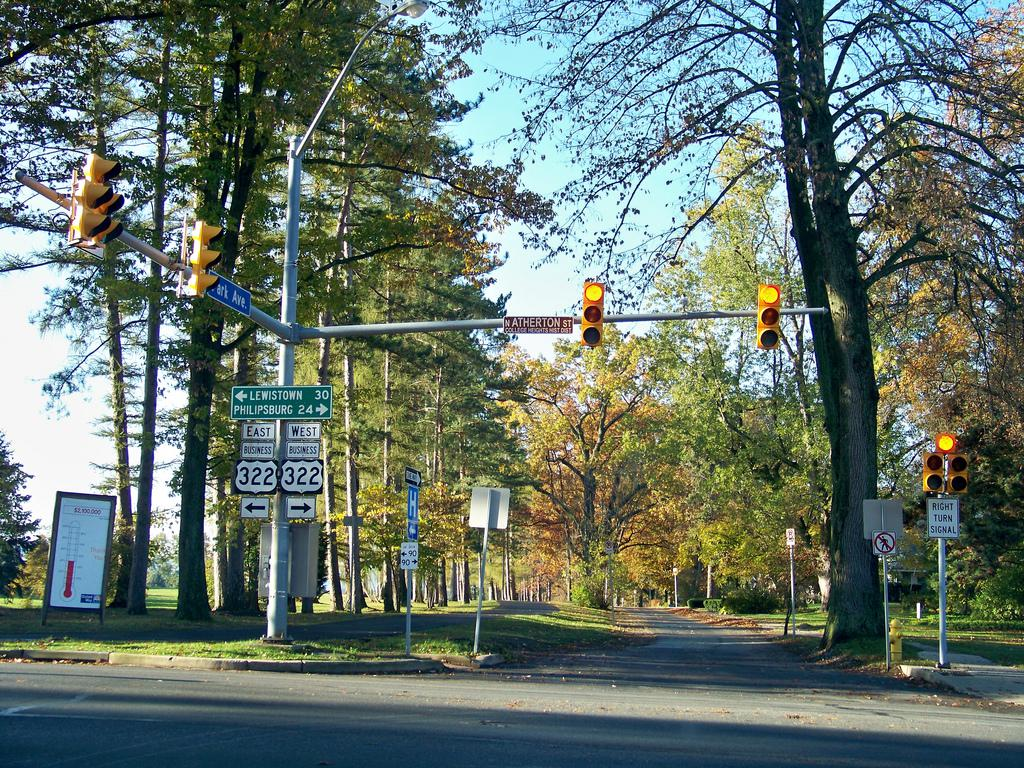Question: why would someone turn left?
Choices:
A. To reach their destination.
B. Because the green traffic arrow says to turn left.
C. Because the sign says left lane must turn left.
D. To take east 322.
Answer with the letter. Answer: D Question: when at this traffic light, what do cars do?
Choices:
A. Go.
B. Proceed with caution.
C. Turn right after looking both ways.
D. Stop.
Answer with the letter. Answer: D Question: what is tall and leafy?
Choices:
A. Trees.
B. Palm trees.
C. Apple trees.
D. Weeds.
Answer with the letter. Answer: A Question: what direction is 322 east?
Choices:
A. Left.
B. Right.
C. North.
D. East.
Answer with the letter. Answer: A Question: what is in the background?
Choices:
A. The ocean.
B. Trees.
C. Kites.
D. Cows.
Answer with the letter. Answer: B Question: what's in the grassy area?
Choices:
A. A thermometer.
B. A water hose.
C. A garden.
D. A sprinkler.
Answer with the letter. Answer: A Question: how far is lewistown?
Choices:
A. 100 miles to the south.
B. About an hour away.
C. About a 45min drive.
D. 30 miles to the east.
Answer with the letter. Answer: D Question: what is shining in the sky?
Choices:
A. The moon.
B. The stars.
C. The sun.
D. The spaceship.
Answer with the letter. Answer: C Question: what does the sign say?
Choices:
A. Share the road.
B. No smoking.
C. West 322.
D. No parking.
Answer with the letter. Answer: C Question: where are the traffic lights?
Choices:
A. On the stop sign.
B. On the rope.
C. On the wooden pole.
D. On a pole.
Answer with the letter. Answer: D Question: where are the traffic lights?
Choices:
A. At a railroad crossing.
B. At the intersection.
C. At a cross walk.
D. In front of the fire station.
Answer with the letter. Answer: B Question: how is the day?
Choices:
A. It's rainy.
B. It's sunny.
C. Terrible.
D. Awesome.
Answer with the letter. Answer: B Question: how much traffic is on the street?
Choices:
A. About 100 cars.
B. A lot.
C. Many cars.
D. None.
Answer with the letter. Answer: D Question: where are the yellow caution lights?
Choices:
A. At an intersection.
B. On the stop lights.
C. At a cross walk.
D. Somewhere you may need to stop.
Answer with the letter. Answer: B Question: where is 322 west?
Choices:
A. One block ahead on the right.
B. Right.
C. Ten miles up the highway.
D. Left.
Answer with the letter. Answer: B 